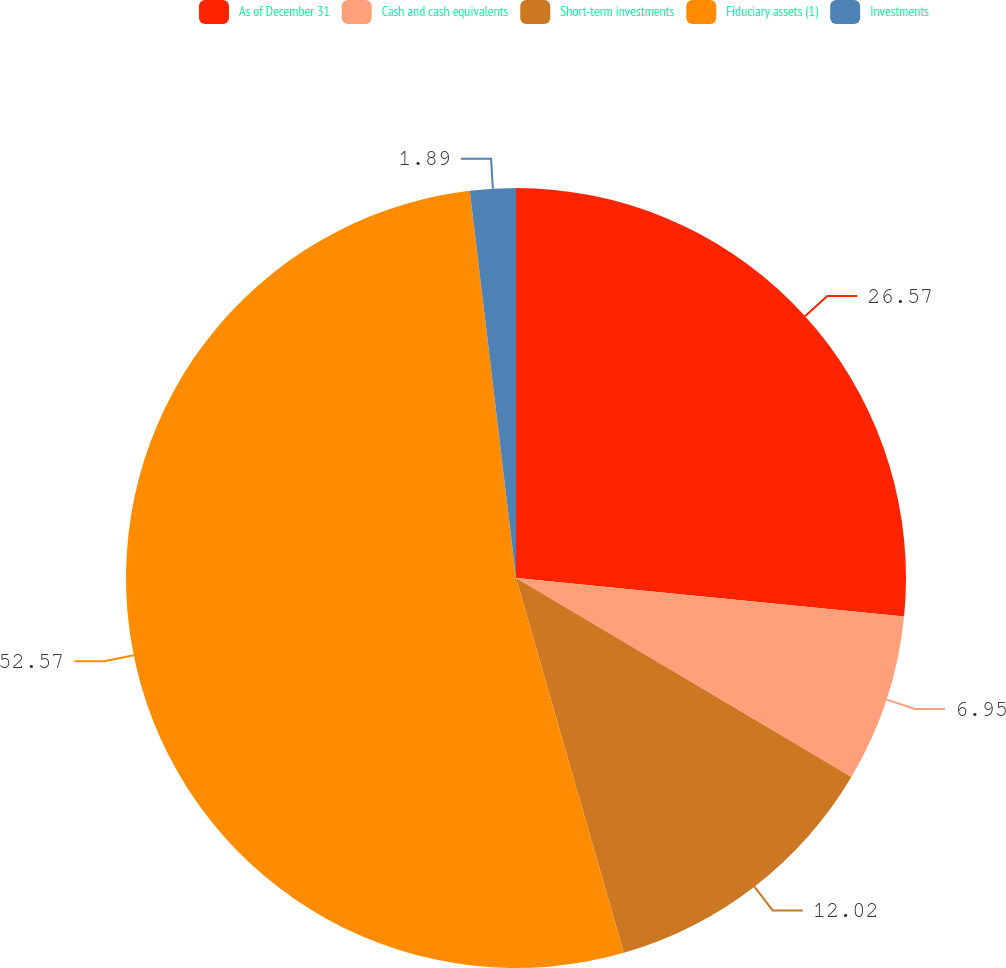Convert chart to OTSL. <chart><loc_0><loc_0><loc_500><loc_500><pie_chart><fcel>As of December 31<fcel>Cash and cash equivalents<fcel>Short-term investments<fcel>Fiduciary assets (1)<fcel>Investments<nl><fcel>26.57%<fcel>6.95%<fcel>12.02%<fcel>52.56%<fcel>1.89%<nl></chart> 